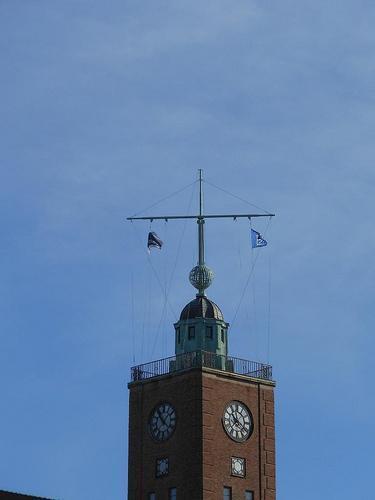How many clocks are there?
Give a very brief answer. 2. How many blue flags are there?
Give a very brief answer. 1. 